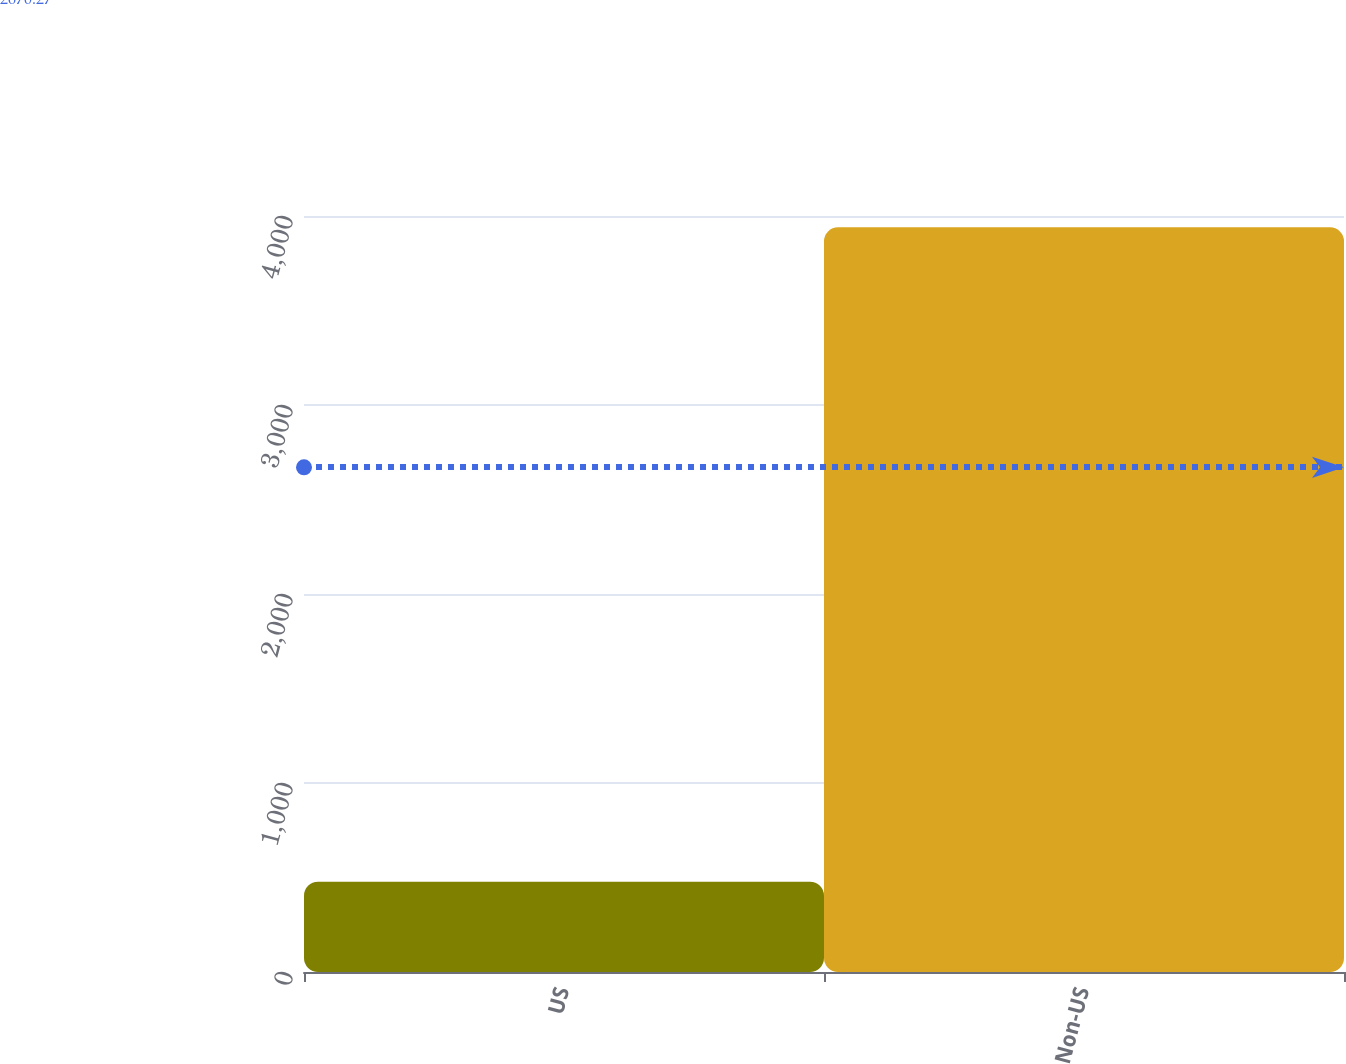<chart> <loc_0><loc_0><loc_500><loc_500><bar_chart><fcel>US<fcel>Non-US<nl><fcel>478<fcel>3940<nl></chart> 